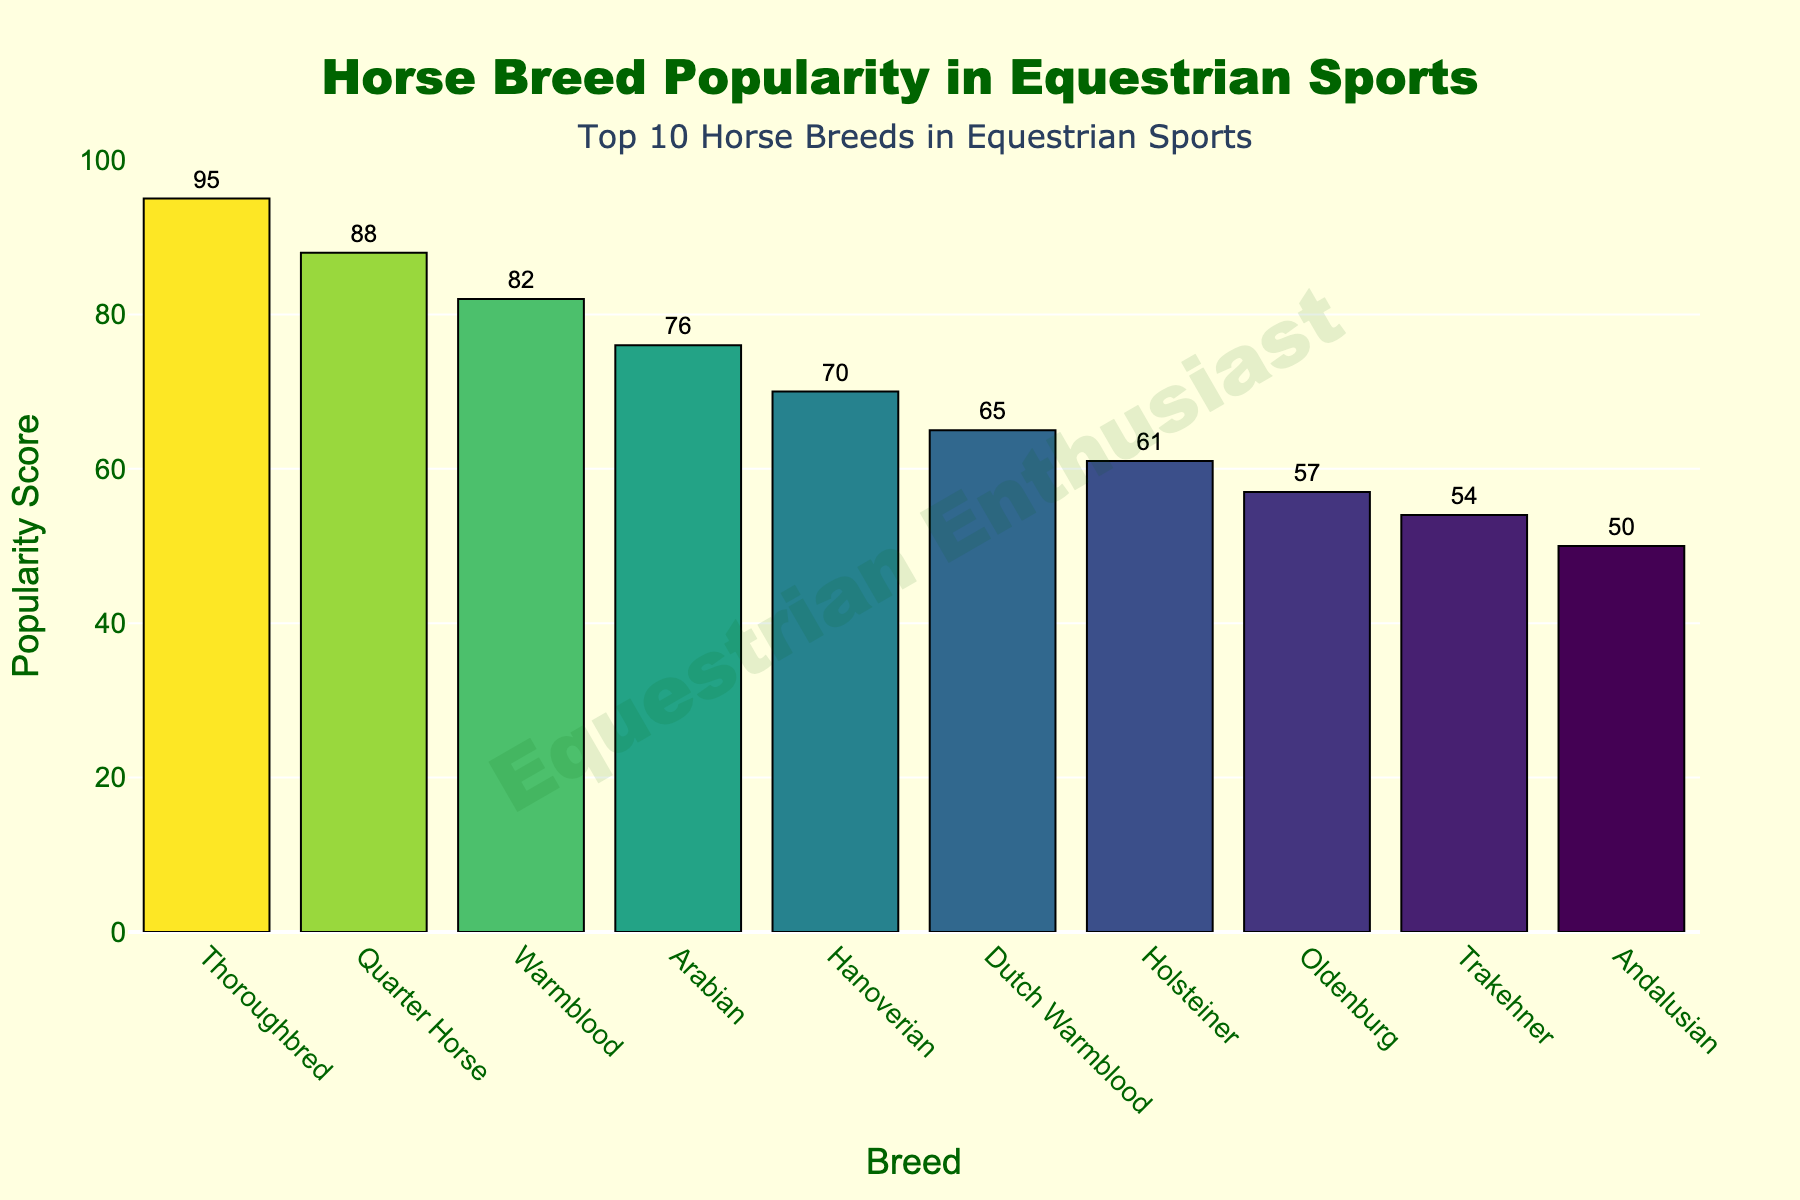What's the most popular horse breed in equestrian sports? The highest bar on the chart represents the breed with the highest popularity score. In this case, the Thoroughbred has the tallest bar with a popularity score of 95.
Answer: Thoroughbred Which breed ranks third in popularity? The third bar from the left often represents the third most popular breed. Here, it is Warmblood with a popularity score of 82.
Answer: Warmblood How much more popular is the Thoroughbred compared to the Andalusian? The Thoroughbred has a popularity score of 95, and the Andalusian has a score of 50. Subtracting 50 from 95 gives the difference in popularity, which is 95 - 50 = 45.
Answer: 45 What is the combined popularity score of the top two breeds? The top two breeds are Thoroughbred and Quarter Horse, with popularity scores of 95 and 88, respectively. Adding these gives 95 + 88 = 183.
Answer: 183 Which breed has a popularity score closest to the median of the top 10 breeds? First, identify the popularity scores of the top 10 breeds: 95, 88, 82, 76, 70, 65, 61, 57, 54, 50. The median is the average of the 5th and 6th values: (70 + 65) / 2 = 67.5. The popularity score of Hanoverian (70) is closest to the median (67.5).
Answer: Hanoverian Which breed has the lowest popularity score among the top 10? The shortest bar on the chart indicates the least popular breed in the top 10. The Andalusian has the shortest bar with a popularity score of 50.
Answer: Andalusian How does the popularity of the Dutch Warmblood compare to the Holsteiner? The Dutch Warmblood has a popularity score of 65, and the Holsteiner has a score of 61. Therefore, the Dutch Warmblood is more popular.
Answer: Dutch Warmblood If the popularity score of the Oldenburg increases by 10 points, would it surpass the Holsteiner? The current score for Oldenburg is 57. Increasing it by 10 points gives 57 + 10 = 67. Since the Holsteiner's score is 61, the new score for Oldenburg would surpass it.
Answer: Yes What is the average popularity score of the top 5 breeds? The top 5 breeds are Thoroughbred, Quarter Horse, Warmblood, Arabian, and Hanoverian with scores of 95, 88, 82, 76, and 70 respectively. The sum is 95 + 88 + 82 + 76 + 70 = 411. Dividing by 5 gives the average, 411 / 5 = 82.2.
Answer: 82.2 What is the cumulative popularity score of all Warmblood breeds listed? The Warmblood breeds are Warmblood (82), Dutch Warmblood (65), and Oldenburg (57). Summing these scores gives 82 + 65 + 57 = 204.
Answer: 204 